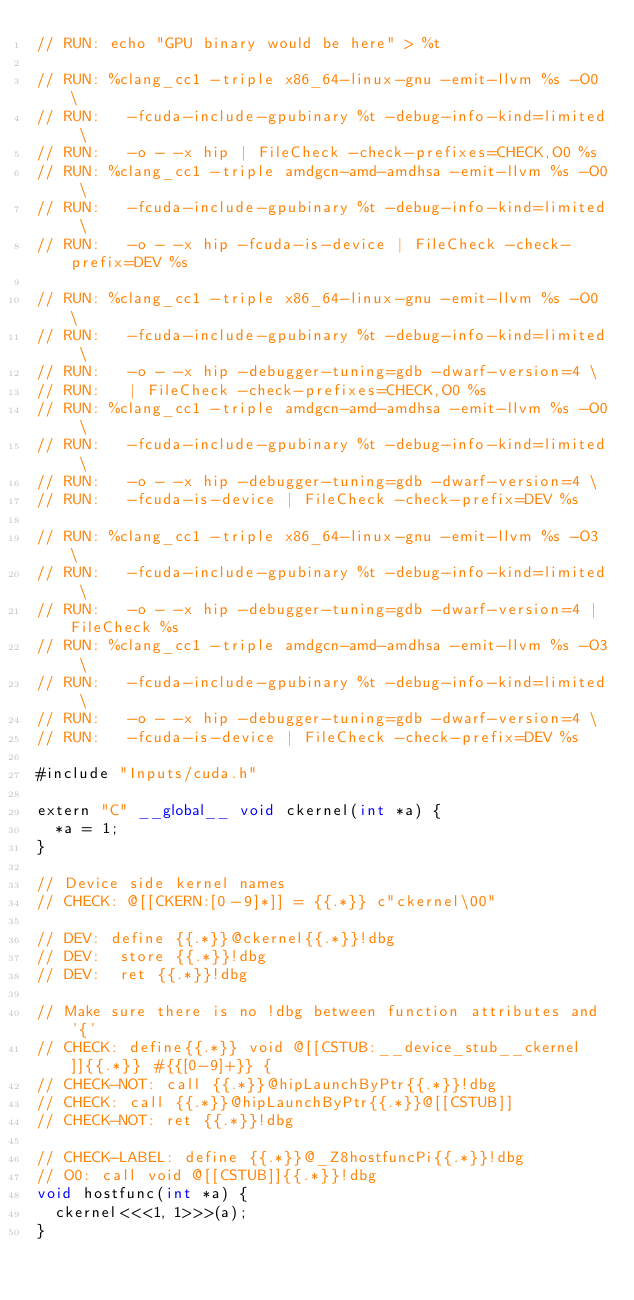<code> <loc_0><loc_0><loc_500><loc_500><_Cuda_>// RUN: echo "GPU binary would be here" > %t

// RUN: %clang_cc1 -triple x86_64-linux-gnu -emit-llvm %s -O0 \
// RUN:   -fcuda-include-gpubinary %t -debug-info-kind=limited \
// RUN:   -o - -x hip | FileCheck -check-prefixes=CHECK,O0 %s
// RUN: %clang_cc1 -triple amdgcn-amd-amdhsa -emit-llvm %s -O0 \
// RUN:   -fcuda-include-gpubinary %t -debug-info-kind=limited \
// RUN:   -o - -x hip -fcuda-is-device | FileCheck -check-prefix=DEV %s

// RUN: %clang_cc1 -triple x86_64-linux-gnu -emit-llvm %s -O0 \
// RUN:   -fcuda-include-gpubinary %t -debug-info-kind=limited \
// RUN:   -o - -x hip -debugger-tuning=gdb -dwarf-version=4 \
// RUN:   | FileCheck -check-prefixes=CHECK,O0 %s
// RUN: %clang_cc1 -triple amdgcn-amd-amdhsa -emit-llvm %s -O0 \
// RUN:   -fcuda-include-gpubinary %t -debug-info-kind=limited \
// RUN:   -o - -x hip -debugger-tuning=gdb -dwarf-version=4 \
// RUN:   -fcuda-is-device | FileCheck -check-prefix=DEV %s

// RUN: %clang_cc1 -triple x86_64-linux-gnu -emit-llvm %s -O3 \
// RUN:   -fcuda-include-gpubinary %t -debug-info-kind=limited \
// RUN:   -o - -x hip -debugger-tuning=gdb -dwarf-version=4 | FileCheck %s
// RUN: %clang_cc1 -triple amdgcn-amd-amdhsa -emit-llvm %s -O3 \
// RUN:   -fcuda-include-gpubinary %t -debug-info-kind=limited \
// RUN:   -o - -x hip -debugger-tuning=gdb -dwarf-version=4 \
// RUN:   -fcuda-is-device | FileCheck -check-prefix=DEV %s

#include "Inputs/cuda.h"

extern "C" __global__ void ckernel(int *a) {
  *a = 1;
}

// Device side kernel names
// CHECK: @[[CKERN:[0-9]*]] = {{.*}} c"ckernel\00"

// DEV: define {{.*}}@ckernel{{.*}}!dbg
// DEV:  store {{.*}}!dbg
// DEV:  ret {{.*}}!dbg

// Make sure there is no !dbg between function attributes and '{'
// CHECK: define{{.*}} void @[[CSTUB:__device_stub__ckernel]]{{.*}} #{{[0-9]+}} {
// CHECK-NOT: call {{.*}}@hipLaunchByPtr{{.*}}!dbg
// CHECK: call {{.*}}@hipLaunchByPtr{{.*}}@[[CSTUB]]
// CHECK-NOT: ret {{.*}}!dbg

// CHECK-LABEL: define {{.*}}@_Z8hostfuncPi{{.*}}!dbg
// O0: call void @[[CSTUB]]{{.*}}!dbg
void hostfunc(int *a) {
  ckernel<<<1, 1>>>(a);
}
</code> 